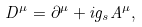<formula> <loc_0><loc_0><loc_500><loc_500>D ^ { \mu } = \partial ^ { \mu } + i g _ { s } A ^ { \mu } ,</formula> 